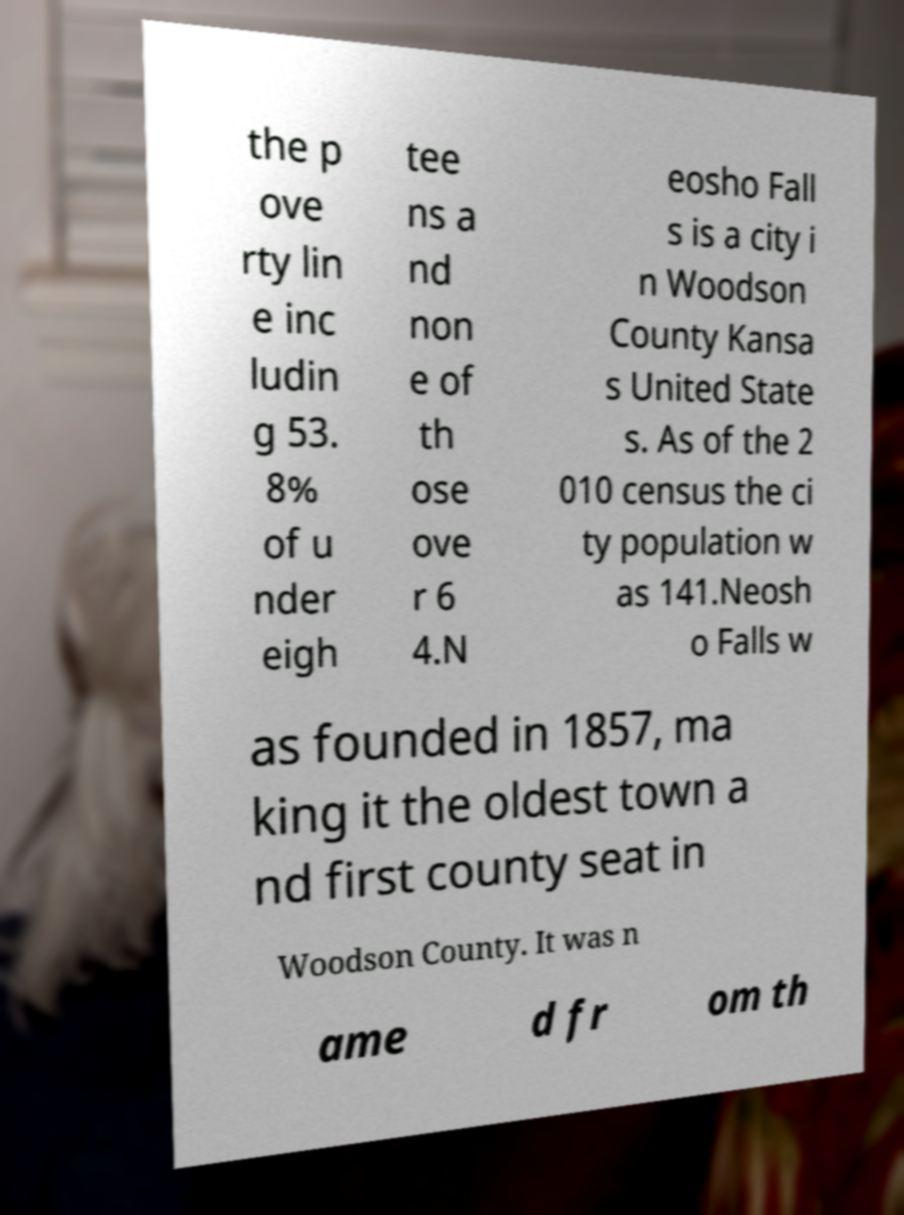Could you extract and type out the text from this image? the p ove rty lin e inc ludin g 53. 8% of u nder eigh tee ns a nd non e of th ose ove r 6 4.N eosho Fall s is a city i n Woodson County Kansa s United State s. As of the 2 010 census the ci ty population w as 141.Neosh o Falls w as founded in 1857, ma king it the oldest town a nd first county seat in Woodson County. It was n ame d fr om th 